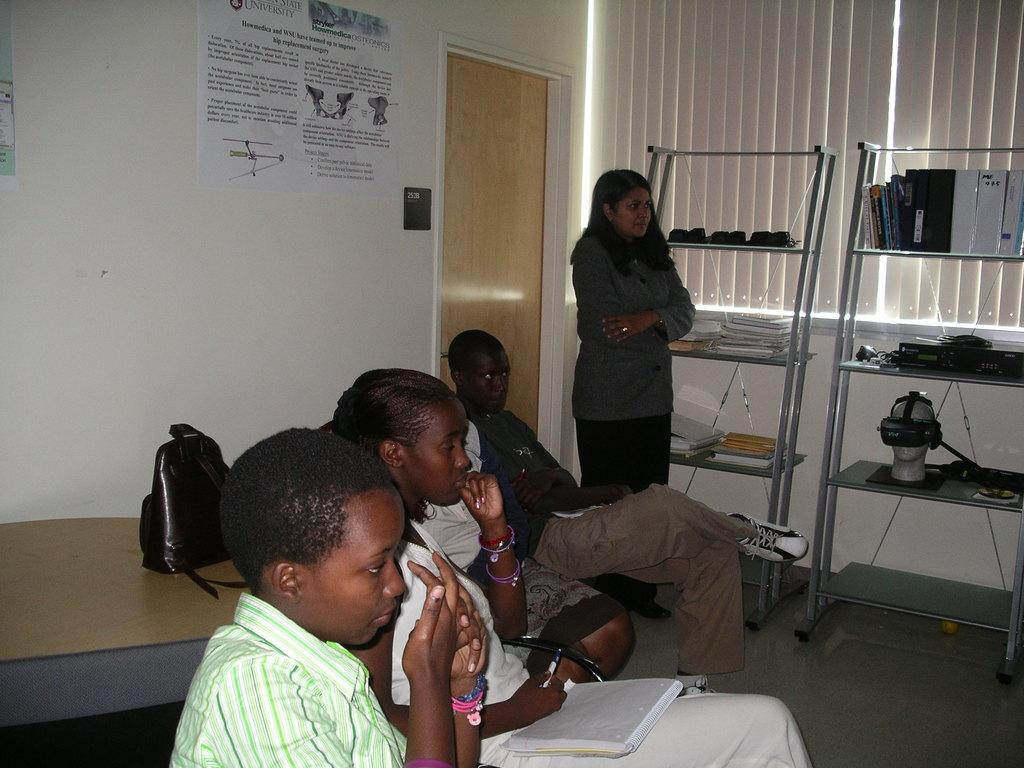What are the people in the image doing? There are persons sitting on chairs in the image. Can you describe the woman in the image? There is a woman standing in the image. What can be seen in the background of the image? There is a door in the background of the image. How many racks are visible in the image? There are two racks in the image. What type of architectural feature is present in the image? There is a big window in the image. What type of cap is the pancake wearing in the image? There is no cap or pancake present in the image. How does the woman plan to burn the racks in the image? There is no indication in the image that the woman plans to burn the racks, and burning is not mentioned in the provided facts. 